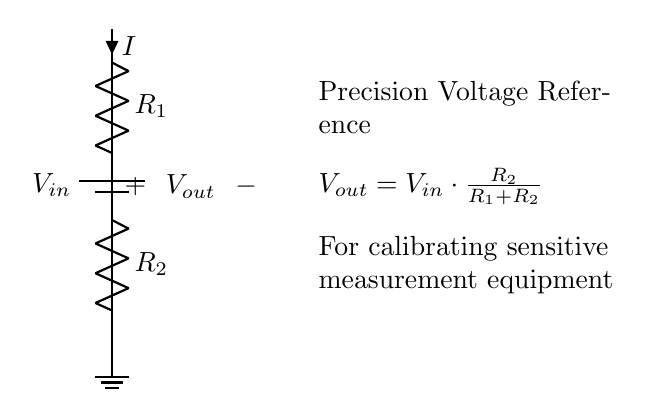What is the input voltage of the circuit? The input voltage is represented by \( V_{in} \), which denotes the potential difference supplied by the battery at the top of the circuit.
Answer: \( V_{in} \) What are the two resistors in the voltage divider? The two resistors are \( R_1 \) and \( R_2 \), indicated in the diagram. \( R_1 \) is the resistor above \( R_2 \), and both are connected in series.
Answer: \( R_1 \) and \( R_2 \) What is the output voltage equation written in the circuit? The equation for output voltage \( V_{out} \) is given as \( V_{out} = V_{in} \cdot \frac{R_2}{R_1 + R_2} \), which is derived from the voltage divider rule, demonstrating how the output voltage is a fraction of the input voltage based on the resistor values.
Answer: \( V_{out} = V_{in} \cdot \frac{R_2}{R_1 + R_2} \) How does increasing \( R_2 \) affect \( V_{out} \)? Increasing \( R_2 \) would increase the fraction \( \frac{R_2}{R_1 + R_2} \), which in turn increases \( V_{out} \) since \( V_{out} \) is directly proportional to \( R_2 \). Thus, higher resistance \( R_2 \) yields a higher output voltage while keeping \( R_1 \) constant.
Answer: Increases \( V_{out} \) What will be the effect of removing \( R_2 \)? Removing \( R_2 \) would short-circuit the lower node, resulting in \( V_{out} \) equal to zero, collapsing the output voltage as there would be no resistance to create a voltage drop across. Therefore, the output voltage can no longer be derived from \( V_{in} \).
Answer: \( V_{out} = 0 \) What is the purpose of this voltage divider circuit? The primary purpose is to create a precision voltage reference for calibrating sensitive measurement equipment, ensuring that the measurement tools can rely on a stable and known output voltage. This facilitates accurate readings and calibrations in sensitive applications.
Answer: Precision voltage reference 